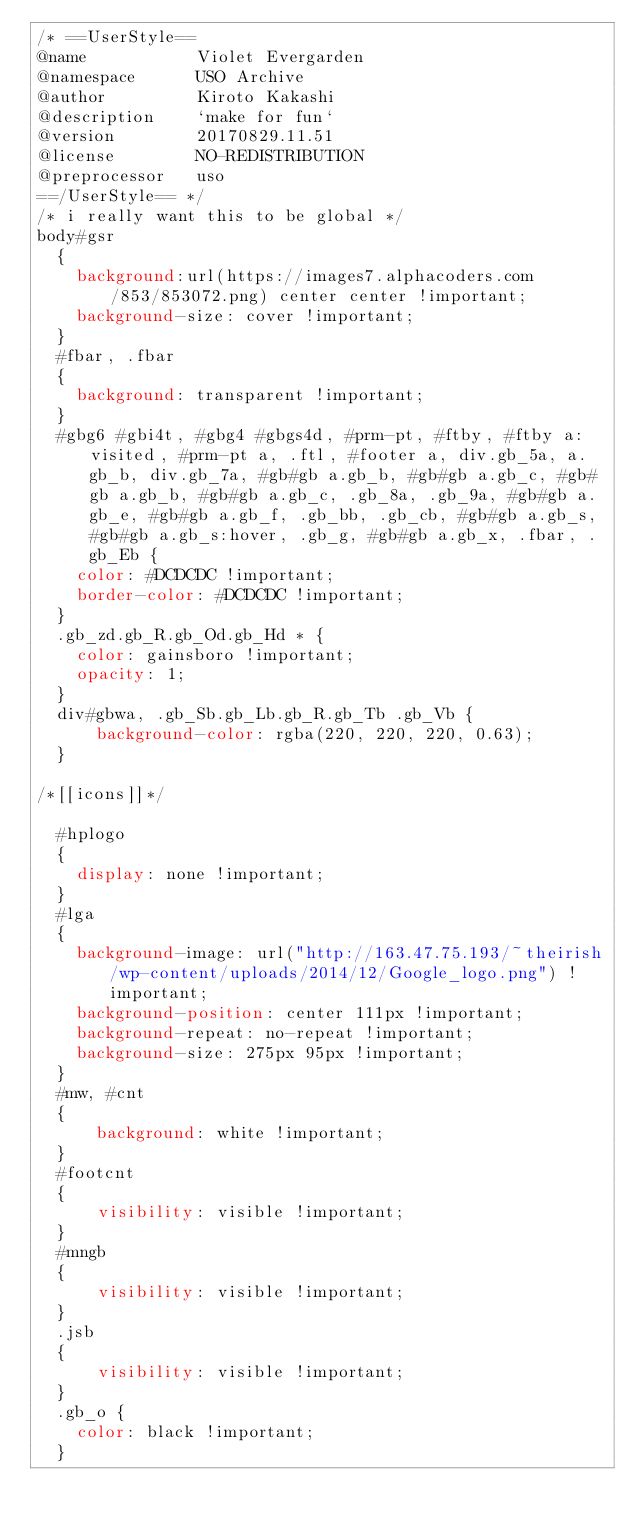Convert code to text. <code><loc_0><loc_0><loc_500><loc_500><_CSS_>/* ==UserStyle==
@name           Violet Evergarden
@namespace      USO Archive
@author         Kiroto Kakashi
@description    `make for fun`
@version        20170829.11.51
@license        NO-REDISTRIBUTION
@preprocessor   uso
==/UserStyle== */
/* i really want this to be global */
body#gsr 
  {
    background:url(https://images7.alphacoders.com/853/853072.png) center center !important;
    background-size: cover !important;
  }
  #fbar, .fbar
  {
    background: transparent !important;
  }
  #gbg6 #gbi4t, #gbg4 #gbgs4d, #prm-pt, #ftby, #ftby a:visited, #prm-pt a, .ftl, #footer a, div.gb_5a, a.gb_b, div.gb_7a, #gb#gb a.gb_b, #gb#gb a.gb_c, #gb#gb a.gb_b, #gb#gb a.gb_c, .gb_8a, .gb_9a, #gb#gb a.gb_e, #gb#gb a.gb_f, .gb_bb, .gb_cb, #gb#gb a.gb_s, #gb#gb a.gb_s:hover, .gb_g, #gb#gb a.gb_x, .fbar, .gb_Eb {
    color: #DCDCDC !important;
    border-color: #DCDCDC !important;
  }
  .gb_zd.gb_R.gb_Od.gb_Hd * {
    color: gainsboro !important;
    opacity: 1;
  }
  div#gbwa, .gb_Sb.gb_Lb.gb_R.gb_Tb .gb_Vb {
      background-color: rgba(220, 220, 220, 0.63);
  }

/*[[icons]]*/

  #hplogo
  {
    display: none !important;
  }
  #lga
  {
    background-image: url("http://163.47.75.193/~theirish/wp-content/uploads/2014/12/Google_logo.png") !important;
    background-position: center 111px !important;
    background-repeat: no-repeat !important;
    background-size: 275px 95px !important;
  }
  #mw, #cnt
  {
      background: white !important;
  }
  #footcnt
  {
      visibility: visible !important;
  }
  #mngb
  {
      visibility: visible !important;
  }
  .jsb
  {
      visibility: visible !important;
  }
  .gb_o {
    color: black !important;
  }</code> 